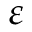<formula> <loc_0><loc_0><loc_500><loc_500>\varepsilon</formula> 